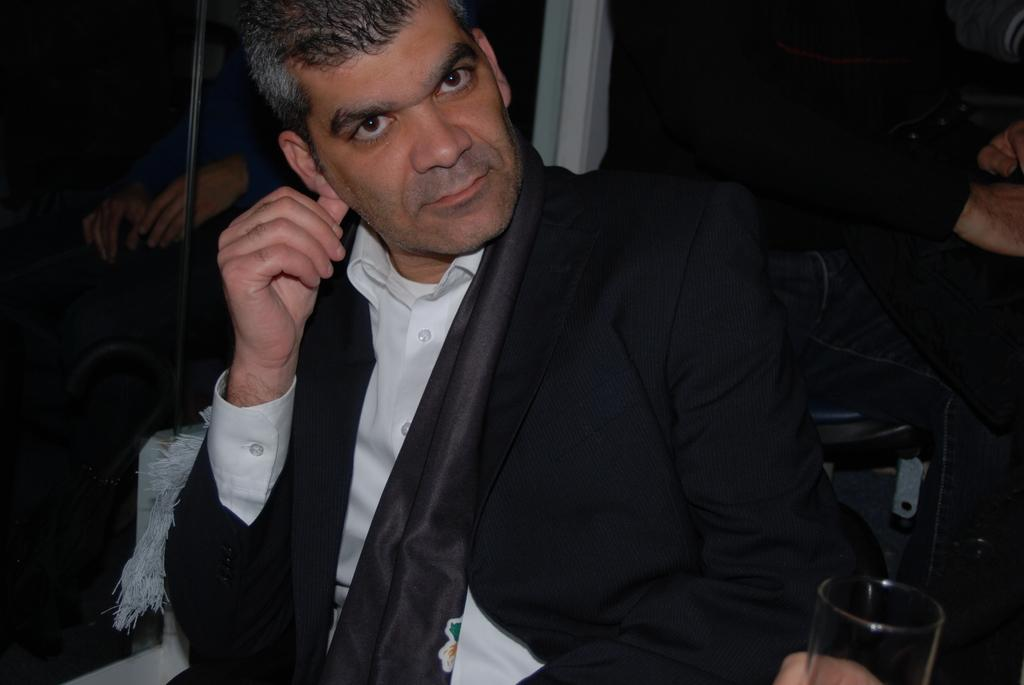What is the man in the image doing? The man is seated in the image. What is the man holding in his hand? The man is holding a glass in his hand. Are there any other people in the image? Yes, there are people seated on the side in the image. What type of spot can be seen on the man's shirt in the image? There is no spot visible on the man's shirt in the image. 